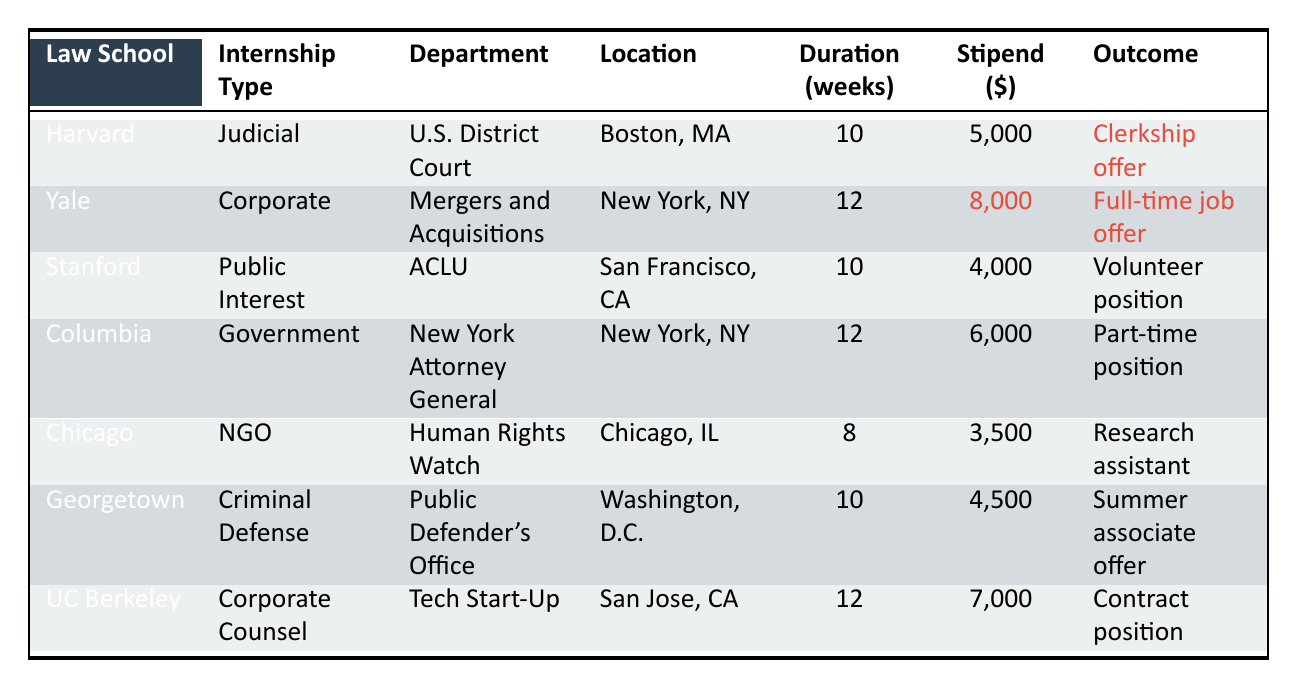What is the maximum stipend offered for internships? The table lists stipends for each internship. The highest stipend is $8,000, which is associated with Yale Law School.
Answer: $8,000 How many weeks does the internship at the ACLU last? The table shows that the internship at the ACLU, associated with Stanford Law School, lasts for 10 weeks.
Answer: 10 weeks Which law school offers a contract position? According to the table, the internship at UC Berkeley offers a contract position.
Answer: UC Berkeley Is there any internship with a stipend below $4,000? Reviewing the table, there is an internship at the University of Chicago Law School with a stipend of $3,500, which is below $4,000.
Answer: Yes What is the average duration of internships listed in the table? To find the average duration, sum the duration of all internships: 10 + 12 + 10 + 12 + 8 + 10 + 12 = 74. There are 7 internships, so the average is 74/7 ≈ 10.57 weeks.
Answer: Approximately 10.57 weeks Which type of internship has the lowest stipend? By examining the stipends, the internship at the University of Chicago has the lowest stipend of $3,500.
Answer: Non-Governmental Organization What proportion of internships leads to a full-time job offer? There are 7 internships total, and 1 of them offers a full-time job (Yale Law School). Therefore, the proportion is 1/7, which equals approximately 14.29%.
Answer: Approximately 14.29% How many internships take place in New York City? The internships at Yale and Columbia law schools are located in New York City, giving a total of 2 internships in that location.
Answer: 2 internships Which internship has the longest duration, and what is that duration? The table shows that both Yale Law School and UC Berkeley have the longest internships of 12 weeks.
Answer: 12 weeks Is it true that all internships provide some form of compensation? Reviewing the table, all listed internships do provide some form of stipend, even if it's low.
Answer: Yes 